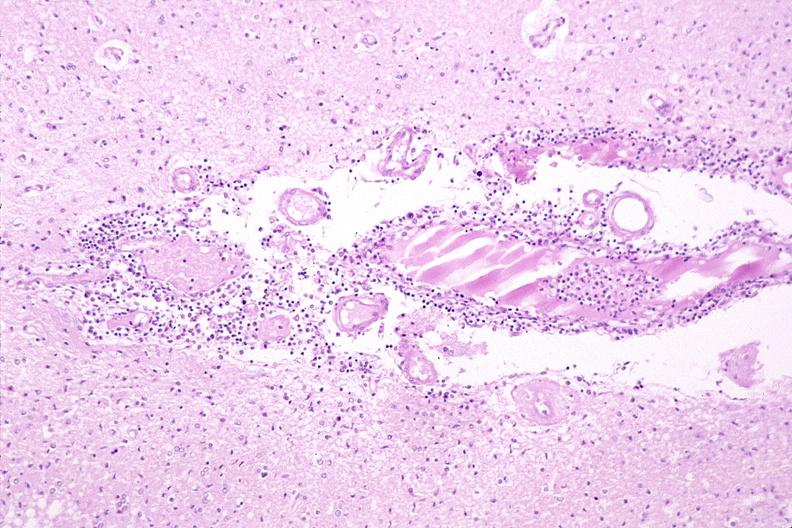does erythrophagocytosis new born show brain, herpes encephalitis?
Answer the question using a single word or phrase. No 